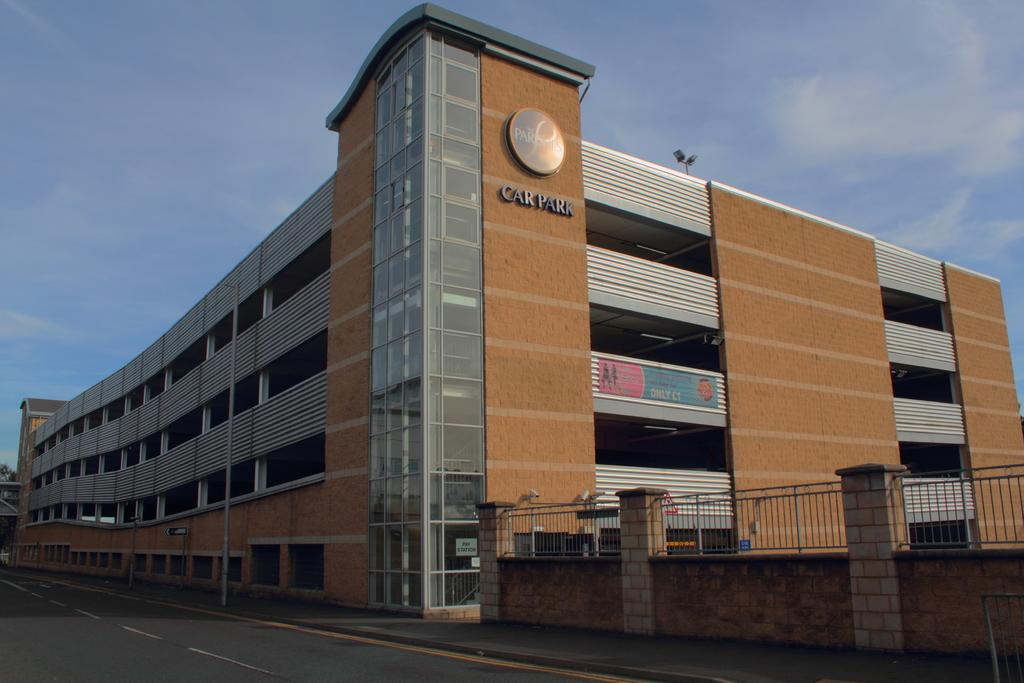What type of path is visible in the image? There is a footpath in the image. What type of structure can be seen in the image? There is a building in the image. What type of barrier is present in the image? There is a wall and a fence in the image. What type of vertical structure is present in the image? There is a pole in the image. What type of signage is present in the image? There are posters in the image. What type of surface is visible in the image? There is a road in the image. What type of background is visible in the image? The sky is visible in the background of the image. How many parcels are being delivered in the image? There are no parcels visible in the image. What country is depicted in the image? The image does not depict any specific country. 